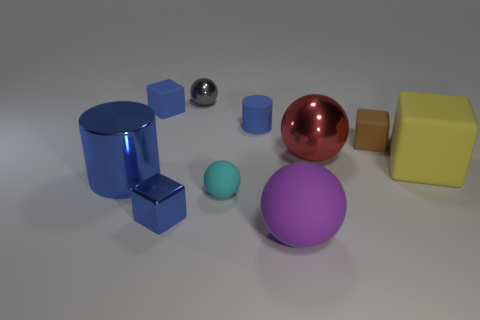Subtract all small blue rubber blocks. How many blocks are left? 3 Subtract all brown balls. How many blue cubes are left? 2 Subtract 2 balls. How many balls are left? 2 Subtract all purple balls. How many balls are left? 3 Subtract all tiny red cubes. Subtract all big rubber blocks. How many objects are left? 9 Add 5 red spheres. How many red spheres are left? 6 Add 3 purple spheres. How many purple spheres exist? 4 Subtract 0 cyan cylinders. How many objects are left? 10 Subtract all cylinders. How many objects are left? 8 Subtract all yellow spheres. Subtract all purple cubes. How many spheres are left? 4 